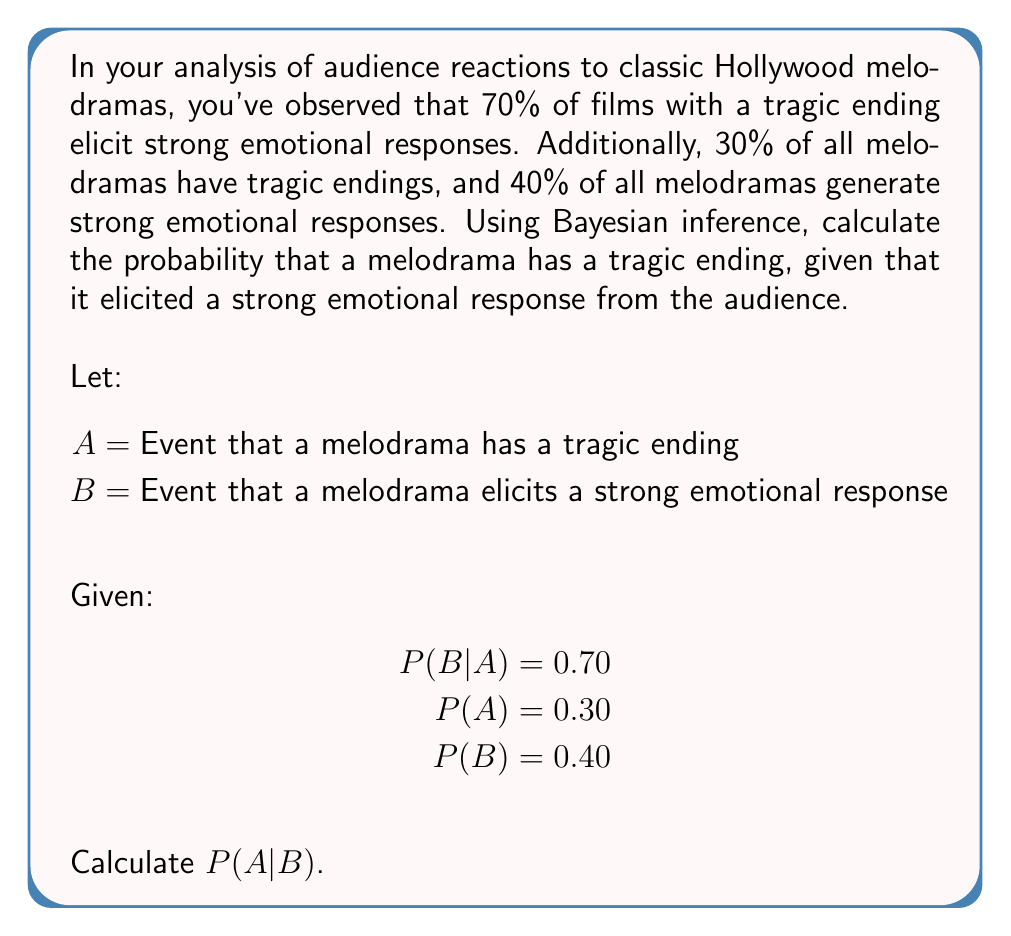Could you help me with this problem? To solve this problem, we'll use Bayes' theorem:

$$ P(A|B) = \frac{P(B|A) \cdot P(A)}{P(B)} $$

Step 1: Identify the given probabilities
P(B|A) = 0.70 (probability of strong emotional response given a tragic ending)
P(A) = 0.30 (probability of a tragic ending)
P(B) = 0.40 (probability of a strong emotional response)

Step 2: Apply Bayes' theorem
$$ P(A|B) = \frac{0.70 \cdot 0.30}{0.40} $$

Step 3: Calculate the numerator
$$ P(A|B) = \frac{0.21}{0.40} $$

Step 4: Perform the division
$$ P(A|B) = 0.525 $$

Therefore, the probability that a melodrama has a tragic ending, given that it elicited a strong emotional response, is 0.525 or 52.5%.
Answer: 0.525 